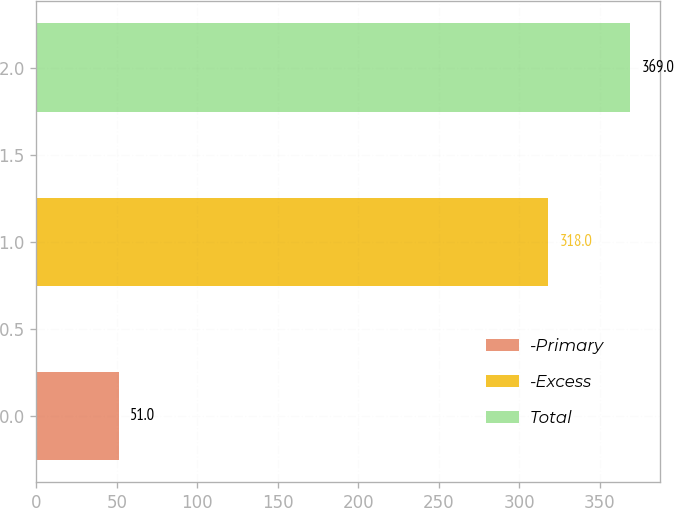Convert chart to OTSL. <chart><loc_0><loc_0><loc_500><loc_500><bar_chart><fcel>-Primary<fcel>-Excess<fcel>Total<nl><fcel>51<fcel>318<fcel>369<nl></chart> 